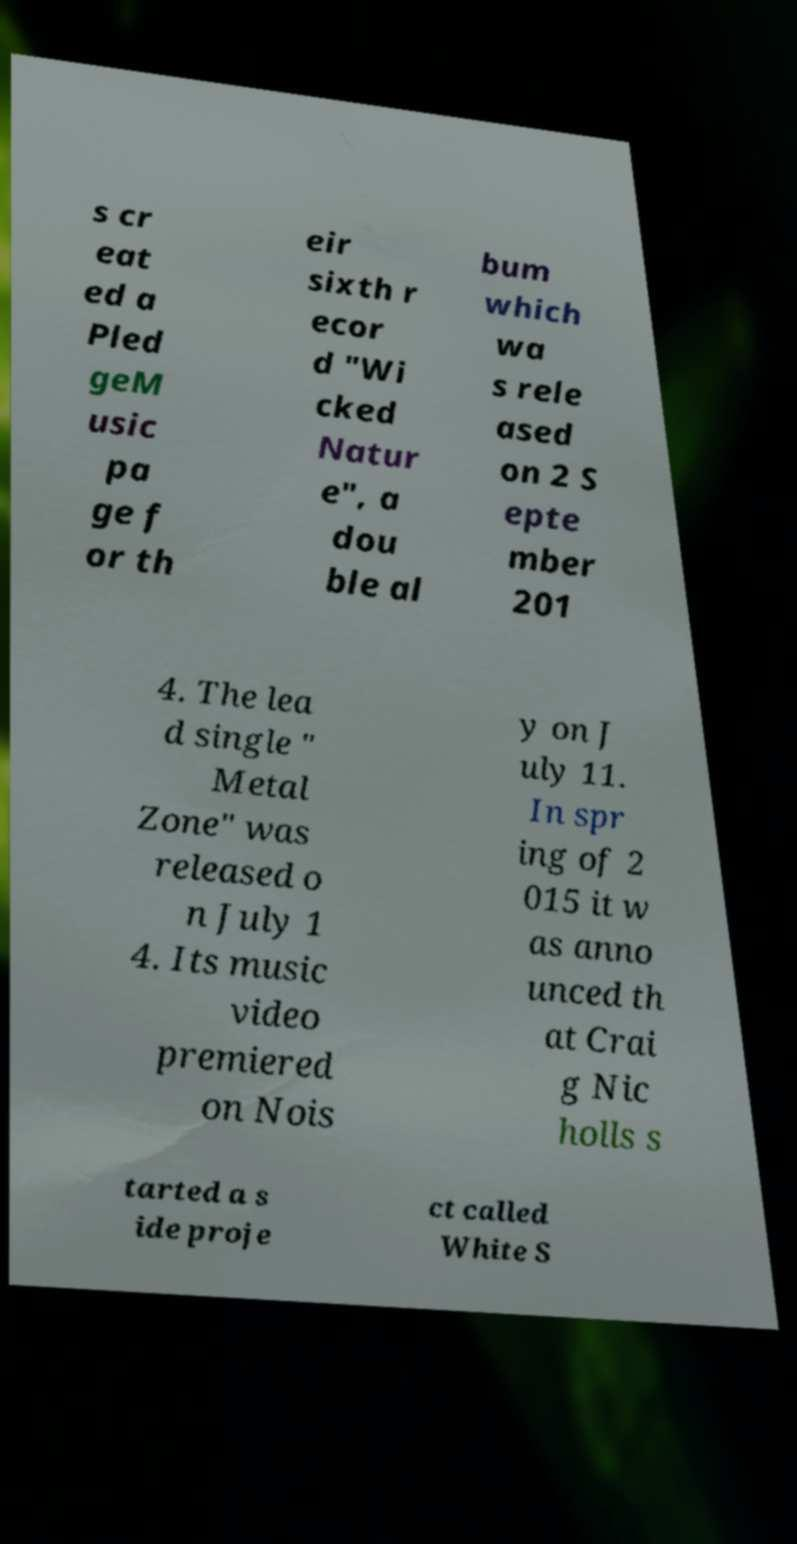Please identify and transcribe the text found in this image. s cr eat ed a Pled geM usic pa ge f or th eir sixth r ecor d "Wi cked Natur e", a dou ble al bum which wa s rele ased on 2 S epte mber 201 4. The lea d single " Metal Zone" was released o n July 1 4. Its music video premiered on Nois y on J uly 11. In spr ing of 2 015 it w as anno unced th at Crai g Nic holls s tarted a s ide proje ct called White S 